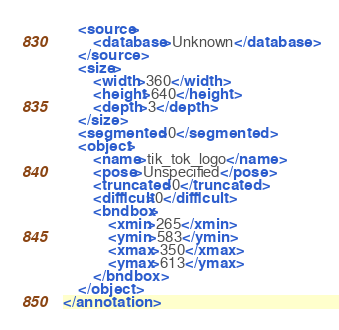Convert code to text. <code><loc_0><loc_0><loc_500><loc_500><_XML_>	<source>
		<database>Unknown</database>
	</source>
	<size>
		<width>360</width>
		<height>640</height>
		<depth>3</depth>
	</size>
	<segmented>0</segmented>
	<object>
		<name>tik_tok_logo</name>
		<pose>Unspecified</pose>
		<truncated>0</truncated>
		<difficult>0</difficult>
		<bndbox>
			<xmin>265</xmin>
			<ymin>583</ymin>
			<xmax>350</xmax>
			<ymax>613</ymax>
		</bndbox>
	</object>
</annotation>
</code> 